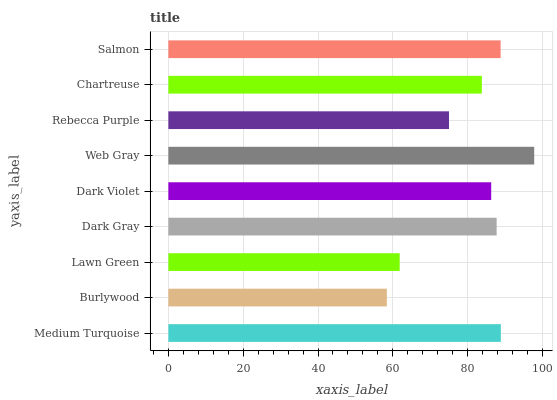Is Burlywood the minimum?
Answer yes or no. Yes. Is Web Gray the maximum?
Answer yes or no. Yes. Is Lawn Green the minimum?
Answer yes or no. No. Is Lawn Green the maximum?
Answer yes or no. No. Is Lawn Green greater than Burlywood?
Answer yes or no. Yes. Is Burlywood less than Lawn Green?
Answer yes or no. Yes. Is Burlywood greater than Lawn Green?
Answer yes or no. No. Is Lawn Green less than Burlywood?
Answer yes or no. No. Is Dark Violet the high median?
Answer yes or no. Yes. Is Dark Violet the low median?
Answer yes or no. Yes. Is Salmon the high median?
Answer yes or no. No. Is Web Gray the low median?
Answer yes or no. No. 